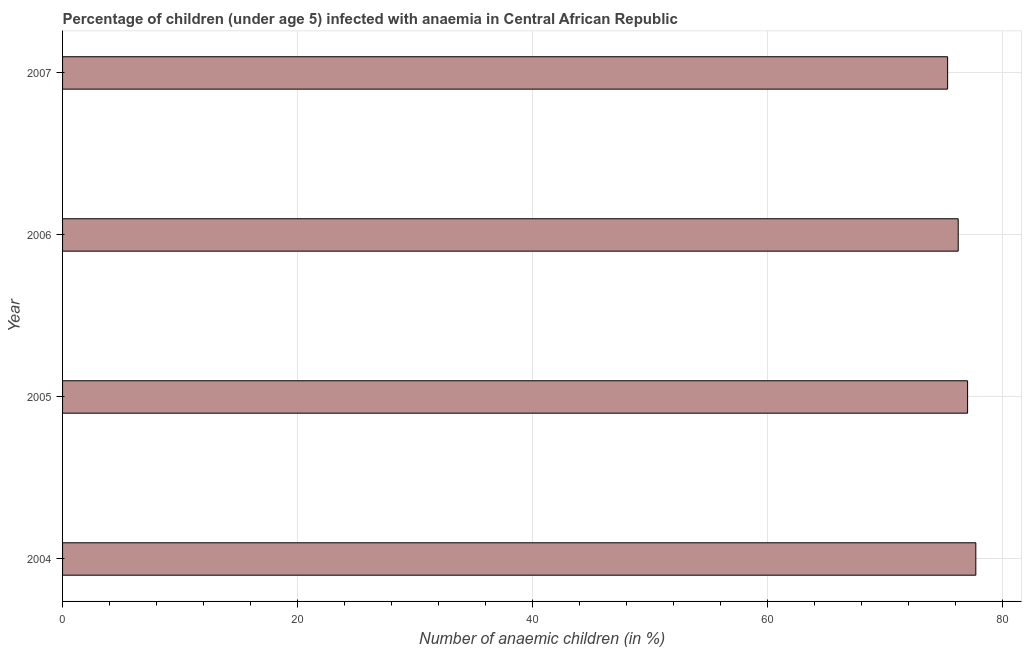Does the graph contain grids?
Keep it short and to the point. Yes. What is the title of the graph?
Offer a very short reply. Percentage of children (under age 5) infected with anaemia in Central African Republic. What is the label or title of the X-axis?
Your response must be concise. Number of anaemic children (in %). What is the label or title of the Y-axis?
Ensure brevity in your answer.  Year. What is the number of anaemic children in 2005?
Provide a short and direct response. 77. Across all years, what is the maximum number of anaemic children?
Make the answer very short. 77.7. Across all years, what is the minimum number of anaemic children?
Your answer should be very brief. 75.3. In which year was the number of anaemic children maximum?
Ensure brevity in your answer.  2004. What is the sum of the number of anaemic children?
Your answer should be very brief. 306.2. What is the average number of anaemic children per year?
Your answer should be compact. 76.55. What is the median number of anaemic children?
Offer a terse response. 76.6. Is the number of anaemic children in 2004 less than that in 2006?
Your answer should be very brief. No. In how many years, is the number of anaemic children greater than the average number of anaemic children taken over all years?
Offer a very short reply. 2. How many bars are there?
Make the answer very short. 4. Are all the bars in the graph horizontal?
Keep it short and to the point. Yes. What is the Number of anaemic children (in %) in 2004?
Keep it short and to the point. 77.7. What is the Number of anaemic children (in %) in 2006?
Give a very brief answer. 76.2. What is the Number of anaemic children (in %) of 2007?
Offer a terse response. 75.3. What is the difference between the Number of anaemic children (in %) in 2005 and 2006?
Keep it short and to the point. 0.8. What is the ratio of the Number of anaemic children (in %) in 2004 to that in 2006?
Offer a very short reply. 1.02. What is the ratio of the Number of anaemic children (in %) in 2004 to that in 2007?
Provide a succinct answer. 1.03. What is the ratio of the Number of anaemic children (in %) in 2006 to that in 2007?
Provide a succinct answer. 1.01. 